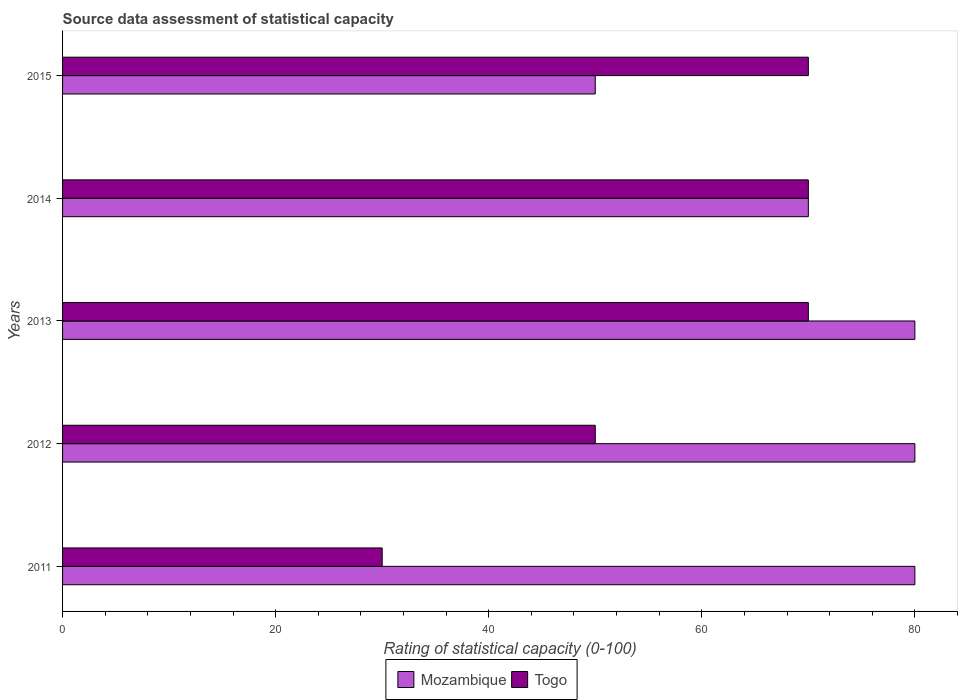How many different coloured bars are there?
Provide a succinct answer. 2. Are the number of bars per tick equal to the number of legend labels?
Make the answer very short. Yes. How many bars are there on the 1st tick from the bottom?
Offer a terse response. 2. What is the rating of statistical capacity in Togo in 2012?
Provide a succinct answer. 50. Across all years, what is the maximum rating of statistical capacity in Togo?
Your response must be concise. 70. Across all years, what is the minimum rating of statistical capacity in Mozambique?
Ensure brevity in your answer.  50. In which year was the rating of statistical capacity in Mozambique maximum?
Provide a succinct answer. 2011. In which year was the rating of statistical capacity in Togo minimum?
Give a very brief answer. 2011. What is the total rating of statistical capacity in Togo in the graph?
Keep it short and to the point. 290. What is the difference between the rating of statistical capacity in Mozambique in 2013 and that in 2014?
Give a very brief answer. 10. What is the average rating of statistical capacity in Mozambique per year?
Give a very brief answer. 72. In how many years, is the rating of statistical capacity in Togo greater than 24 ?
Provide a succinct answer. 5. What is the ratio of the rating of statistical capacity in Mozambique in 2012 to that in 2014?
Your response must be concise. 1.14. What is the difference between the highest and the second highest rating of statistical capacity in Togo?
Offer a very short reply. 0. What is the difference between the highest and the lowest rating of statistical capacity in Mozambique?
Ensure brevity in your answer.  30. In how many years, is the rating of statistical capacity in Togo greater than the average rating of statistical capacity in Togo taken over all years?
Your answer should be very brief. 3. What does the 2nd bar from the top in 2014 represents?
Your response must be concise. Mozambique. What does the 1st bar from the bottom in 2015 represents?
Your answer should be very brief. Mozambique. Are all the bars in the graph horizontal?
Keep it short and to the point. Yes. What is the difference between two consecutive major ticks on the X-axis?
Offer a terse response. 20. Does the graph contain any zero values?
Your response must be concise. No. Does the graph contain grids?
Keep it short and to the point. No. How are the legend labels stacked?
Offer a terse response. Horizontal. What is the title of the graph?
Your response must be concise. Source data assessment of statistical capacity. Does "Turkey" appear as one of the legend labels in the graph?
Provide a succinct answer. No. What is the label or title of the X-axis?
Keep it short and to the point. Rating of statistical capacity (0-100). What is the Rating of statistical capacity (0-100) in Togo in 2011?
Make the answer very short. 30. What is the Rating of statistical capacity (0-100) in Togo in 2012?
Ensure brevity in your answer.  50. What is the Rating of statistical capacity (0-100) of Mozambique in 2013?
Your answer should be compact. 80. What is the Rating of statistical capacity (0-100) of Mozambique in 2014?
Provide a short and direct response. 70. What is the Rating of statistical capacity (0-100) in Togo in 2014?
Provide a short and direct response. 70. What is the Rating of statistical capacity (0-100) in Mozambique in 2015?
Offer a terse response. 50. Across all years, what is the maximum Rating of statistical capacity (0-100) of Mozambique?
Ensure brevity in your answer.  80. Across all years, what is the maximum Rating of statistical capacity (0-100) in Togo?
Keep it short and to the point. 70. Across all years, what is the minimum Rating of statistical capacity (0-100) of Togo?
Give a very brief answer. 30. What is the total Rating of statistical capacity (0-100) in Mozambique in the graph?
Keep it short and to the point. 360. What is the total Rating of statistical capacity (0-100) in Togo in the graph?
Provide a succinct answer. 290. What is the difference between the Rating of statistical capacity (0-100) of Mozambique in 2011 and that in 2013?
Offer a terse response. 0. What is the difference between the Rating of statistical capacity (0-100) in Togo in 2011 and that in 2013?
Your response must be concise. -40. What is the difference between the Rating of statistical capacity (0-100) of Mozambique in 2011 and that in 2015?
Keep it short and to the point. 30. What is the difference between the Rating of statistical capacity (0-100) in Togo in 2011 and that in 2015?
Keep it short and to the point. -40. What is the difference between the Rating of statistical capacity (0-100) in Mozambique in 2012 and that in 2013?
Your response must be concise. 0. What is the difference between the Rating of statistical capacity (0-100) of Mozambique in 2012 and that in 2014?
Offer a terse response. 10. What is the difference between the Rating of statistical capacity (0-100) in Togo in 2012 and that in 2014?
Ensure brevity in your answer.  -20. What is the difference between the Rating of statistical capacity (0-100) in Mozambique in 2012 and that in 2015?
Offer a terse response. 30. What is the difference between the Rating of statistical capacity (0-100) of Togo in 2013 and that in 2015?
Make the answer very short. 0. What is the difference between the Rating of statistical capacity (0-100) of Mozambique in 2014 and that in 2015?
Your response must be concise. 20. What is the difference between the Rating of statistical capacity (0-100) in Mozambique in 2011 and the Rating of statistical capacity (0-100) in Togo in 2015?
Your answer should be compact. 10. What is the difference between the Rating of statistical capacity (0-100) of Mozambique in 2012 and the Rating of statistical capacity (0-100) of Togo in 2015?
Make the answer very short. 10. What is the difference between the Rating of statistical capacity (0-100) of Mozambique in 2013 and the Rating of statistical capacity (0-100) of Togo in 2014?
Offer a terse response. 10. What is the difference between the Rating of statistical capacity (0-100) in Mozambique in 2013 and the Rating of statistical capacity (0-100) in Togo in 2015?
Your answer should be very brief. 10. What is the difference between the Rating of statistical capacity (0-100) of Mozambique in 2014 and the Rating of statistical capacity (0-100) of Togo in 2015?
Ensure brevity in your answer.  0. What is the average Rating of statistical capacity (0-100) in Togo per year?
Your answer should be compact. 58. In the year 2011, what is the difference between the Rating of statistical capacity (0-100) of Mozambique and Rating of statistical capacity (0-100) of Togo?
Provide a short and direct response. 50. What is the ratio of the Rating of statistical capacity (0-100) in Mozambique in 2011 to that in 2012?
Offer a very short reply. 1. What is the ratio of the Rating of statistical capacity (0-100) in Togo in 2011 to that in 2012?
Your answer should be compact. 0.6. What is the ratio of the Rating of statistical capacity (0-100) in Mozambique in 2011 to that in 2013?
Offer a very short reply. 1. What is the ratio of the Rating of statistical capacity (0-100) of Togo in 2011 to that in 2013?
Offer a very short reply. 0.43. What is the ratio of the Rating of statistical capacity (0-100) of Togo in 2011 to that in 2014?
Make the answer very short. 0.43. What is the ratio of the Rating of statistical capacity (0-100) in Togo in 2011 to that in 2015?
Give a very brief answer. 0.43. What is the ratio of the Rating of statistical capacity (0-100) in Mozambique in 2012 to that in 2014?
Your answer should be compact. 1.14. What is the ratio of the Rating of statistical capacity (0-100) in Togo in 2012 to that in 2014?
Offer a terse response. 0.71. What is the ratio of the Rating of statistical capacity (0-100) in Togo in 2012 to that in 2015?
Your response must be concise. 0.71. What is the ratio of the Rating of statistical capacity (0-100) in Mozambique in 2013 to that in 2014?
Your answer should be very brief. 1.14. What is the ratio of the Rating of statistical capacity (0-100) of Mozambique in 2013 to that in 2015?
Your answer should be very brief. 1.6. What is the ratio of the Rating of statistical capacity (0-100) in Togo in 2014 to that in 2015?
Keep it short and to the point. 1. What is the difference between the highest and the second highest Rating of statistical capacity (0-100) in Togo?
Keep it short and to the point. 0. What is the difference between the highest and the lowest Rating of statistical capacity (0-100) of Mozambique?
Your response must be concise. 30. What is the difference between the highest and the lowest Rating of statistical capacity (0-100) in Togo?
Your answer should be compact. 40. 